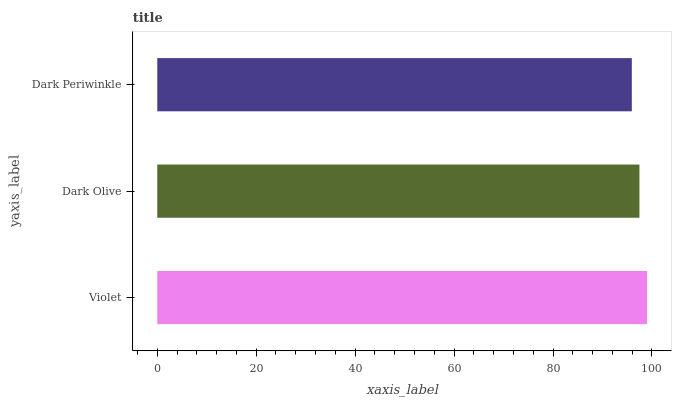Is Dark Periwinkle the minimum?
Answer yes or no. Yes. Is Violet the maximum?
Answer yes or no. Yes. Is Dark Olive the minimum?
Answer yes or no. No. Is Dark Olive the maximum?
Answer yes or no. No. Is Violet greater than Dark Olive?
Answer yes or no. Yes. Is Dark Olive less than Violet?
Answer yes or no. Yes. Is Dark Olive greater than Violet?
Answer yes or no. No. Is Violet less than Dark Olive?
Answer yes or no. No. Is Dark Olive the high median?
Answer yes or no. Yes. Is Dark Olive the low median?
Answer yes or no. Yes. Is Violet the high median?
Answer yes or no. No. Is Dark Periwinkle the low median?
Answer yes or no. No. 